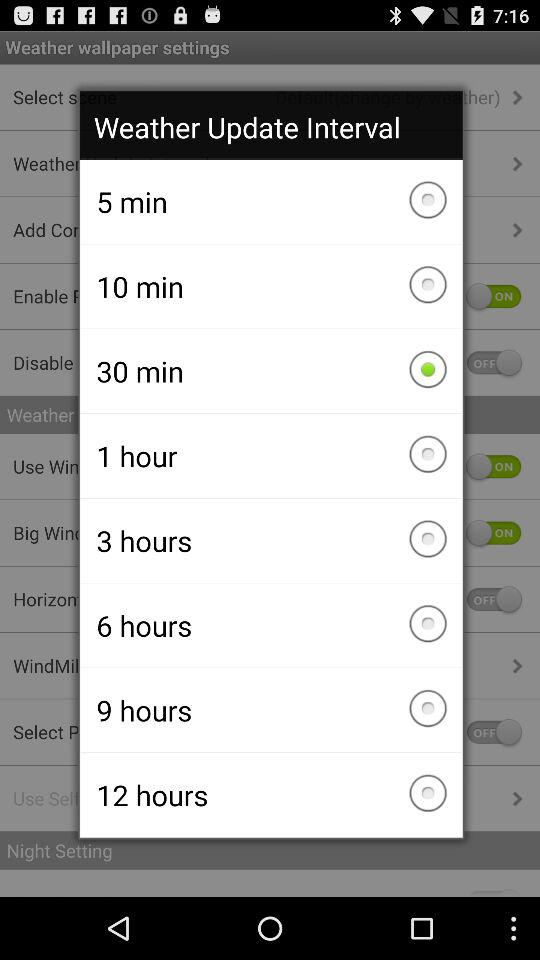What interval has been selected for the "Weather Update"? The selected interval is 30 minutes. 